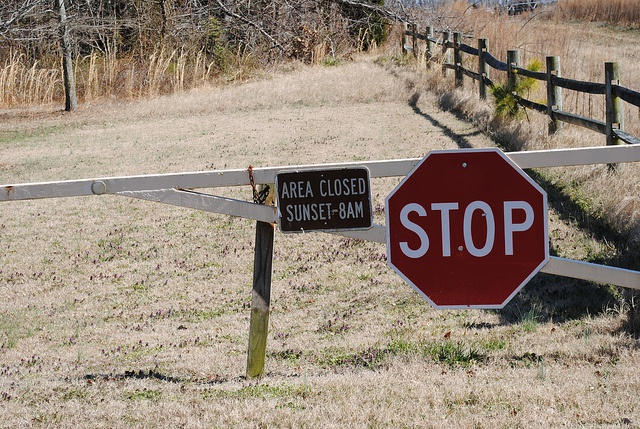Describe the objects in this image and their specific colors. I can see a stop sign in gray and maroon tones in this image. 